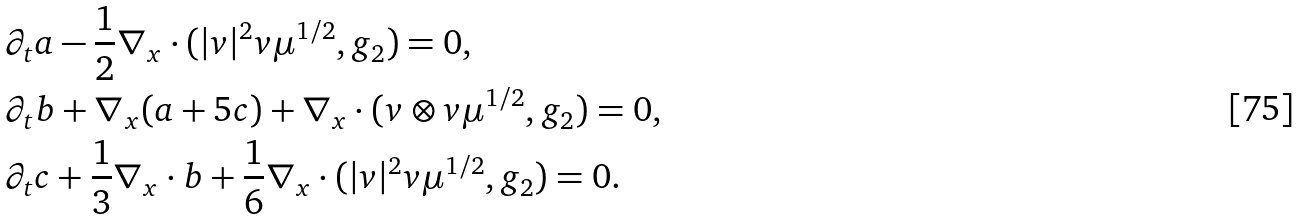<formula> <loc_0><loc_0><loc_500><loc_500>& \partial _ { t } a - \frac { 1 } { 2 } \nabla _ { x } \cdot ( | v | ^ { 2 } v \mu ^ { 1 / 2 } , g _ { 2 } ) = 0 , \\ & \partial _ { t } b + \nabla _ { x } ( a + 5 c ) + \nabla _ { x } \cdot ( v \otimes v \mu ^ { 1 / 2 } , g _ { 2 } ) = 0 , \\ & \partial _ { t } c + \frac { 1 } { 3 } \nabla _ { x } \cdot b + \frac { 1 } { 6 } \nabla _ { x } \cdot ( | v | ^ { 2 } v \mu ^ { 1 / 2 } , g _ { 2 } ) = 0 .</formula> 